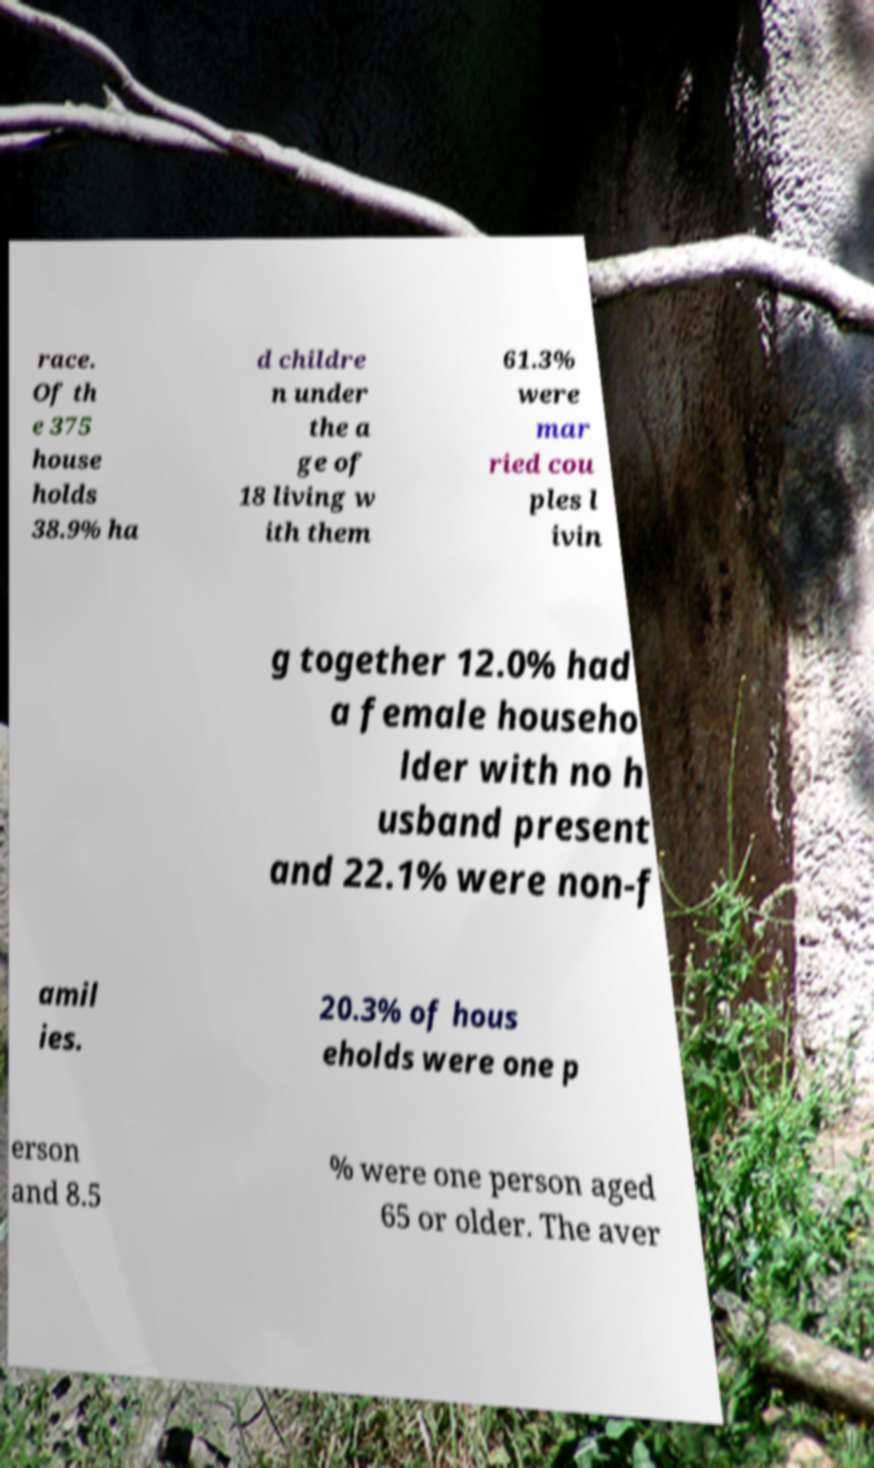For documentation purposes, I need the text within this image transcribed. Could you provide that? race. Of th e 375 house holds 38.9% ha d childre n under the a ge of 18 living w ith them 61.3% were mar ried cou ples l ivin g together 12.0% had a female househo lder with no h usband present and 22.1% were non-f amil ies. 20.3% of hous eholds were one p erson and 8.5 % were one person aged 65 or older. The aver 